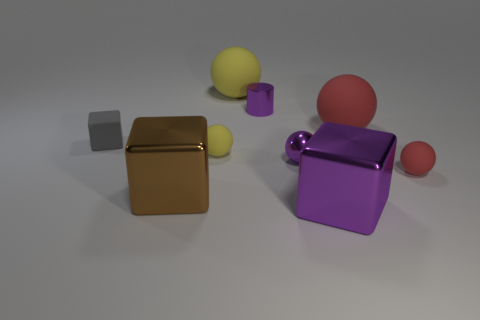Subtract all purple spheres. How many spheres are left? 4 Subtract 1 spheres. How many spheres are left? 4 Subtract all gray balls. Subtract all green blocks. How many balls are left? 5 Add 1 small purple spheres. How many objects exist? 10 Subtract all cylinders. How many objects are left? 8 Add 2 purple metal blocks. How many purple metal blocks are left? 3 Add 5 tiny purple spheres. How many tiny purple spheres exist? 6 Subtract 0 red cubes. How many objects are left? 9 Subtract all small matte cubes. Subtract all tiny rubber things. How many objects are left? 5 